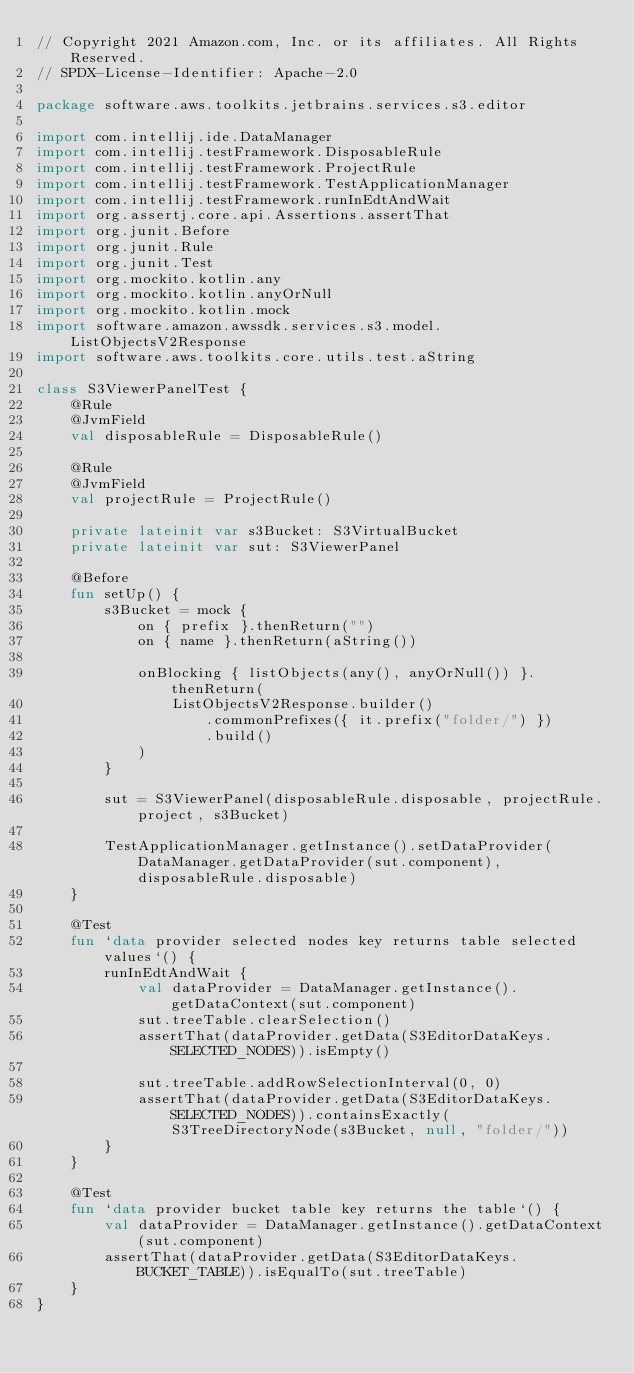Convert code to text. <code><loc_0><loc_0><loc_500><loc_500><_Kotlin_>// Copyright 2021 Amazon.com, Inc. or its affiliates. All Rights Reserved.
// SPDX-License-Identifier: Apache-2.0

package software.aws.toolkits.jetbrains.services.s3.editor

import com.intellij.ide.DataManager
import com.intellij.testFramework.DisposableRule
import com.intellij.testFramework.ProjectRule
import com.intellij.testFramework.TestApplicationManager
import com.intellij.testFramework.runInEdtAndWait
import org.assertj.core.api.Assertions.assertThat
import org.junit.Before
import org.junit.Rule
import org.junit.Test
import org.mockito.kotlin.any
import org.mockito.kotlin.anyOrNull
import org.mockito.kotlin.mock
import software.amazon.awssdk.services.s3.model.ListObjectsV2Response
import software.aws.toolkits.core.utils.test.aString

class S3ViewerPanelTest {
    @Rule
    @JvmField
    val disposableRule = DisposableRule()

    @Rule
    @JvmField
    val projectRule = ProjectRule()

    private lateinit var s3Bucket: S3VirtualBucket
    private lateinit var sut: S3ViewerPanel

    @Before
    fun setUp() {
        s3Bucket = mock {
            on { prefix }.thenReturn("")
            on { name }.thenReturn(aString())

            onBlocking { listObjects(any(), anyOrNull()) }.thenReturn(
                ListObjectsV2Response.builder()
                    .commonPrefixes({ it.prefix("folder/") })
                    .build()
            )
        }

        sut = S3ViewerPanel(disposableRule.disposable, projectRule.project, s3Bucket)

        TestApplicationManager.getInstance().setDataProvider(DataManager.getDataProvider(sut.component), disposableRule.disposable)
    }

    @Test
    fun `data provider selected nodes key returns table selected values`() {
        runInEdtAndWait {
            val dataProvider = DataManager.getInstance().getDataContext(sut.component)
            sut.treeTable.clearSelection()
            assertThat(dataProvider.getData(S3EditorDataKeys.SELECTED_NODES)).isEmpty()

            sut.treeTable.addRowSelectionInterval(0, 0)
            assertThat(dataProvider.getData(S3EditorDataKeys.SELECTED_NODES)).containsExactly(S3TreeDirectoryNode(s3Bucket, null, "folder/"))
        }
    }

    @Test
    fun `data provider bucket table key returns the table`() {
        val dataProvider = DataManager.getInstance().getDataContext(sut.component)
        assertThat(dataProvider.getData(S3EditorDataKeys.BUCKET_TABLE)).isEqualTo(sut.treeTable)
    }
}
</code> 